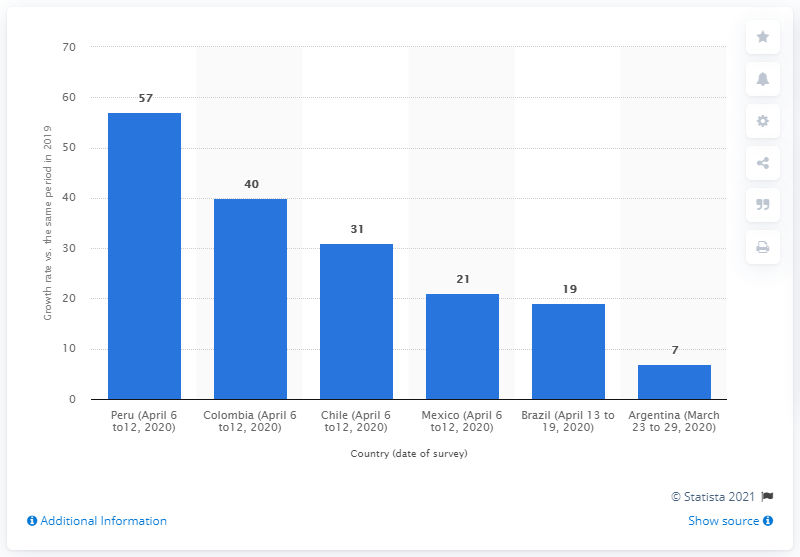Mention a couple of crucial points in this snapshot. The amount of daily TV time for Mexico increased by 21%. The highest increase in TV viewing in Peru was 57%. 